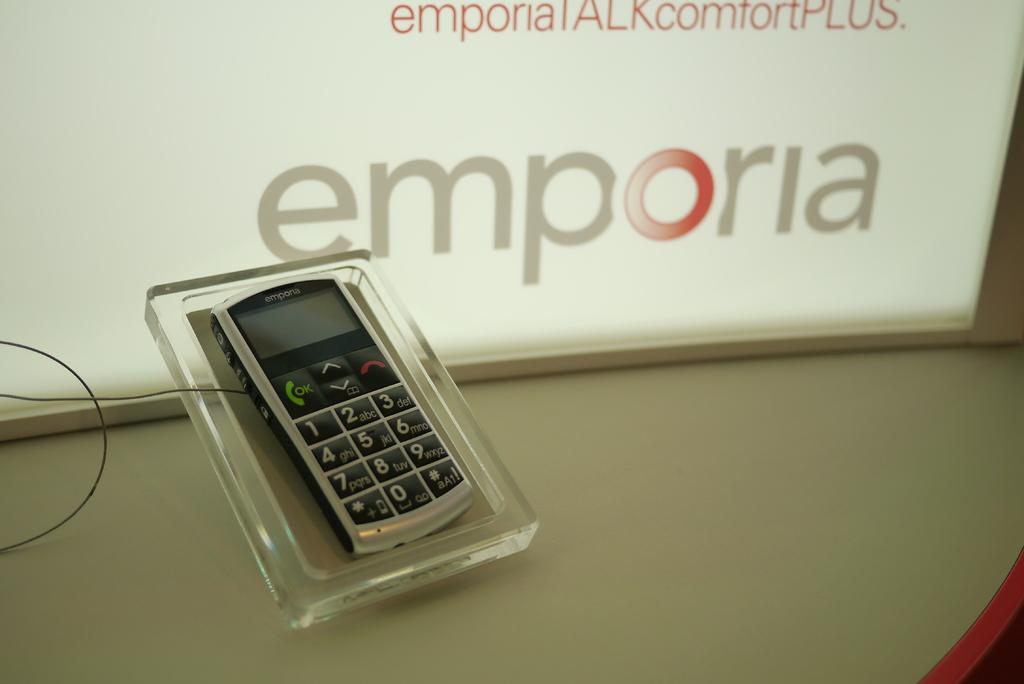<image>
Provide a brief description of the given image. An Emporia brand phone is on display at a store. 